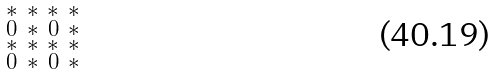Convert formula to latex. <formula><loc_0><loc_0><loc_500><loc_500>\begin{smallmatrix} * & * & * & * \\ 0 & * & 0 & * \\ * & * & * & * \\ 0 & * & 0 & * \\ \end{smallmatrix}</formula> 